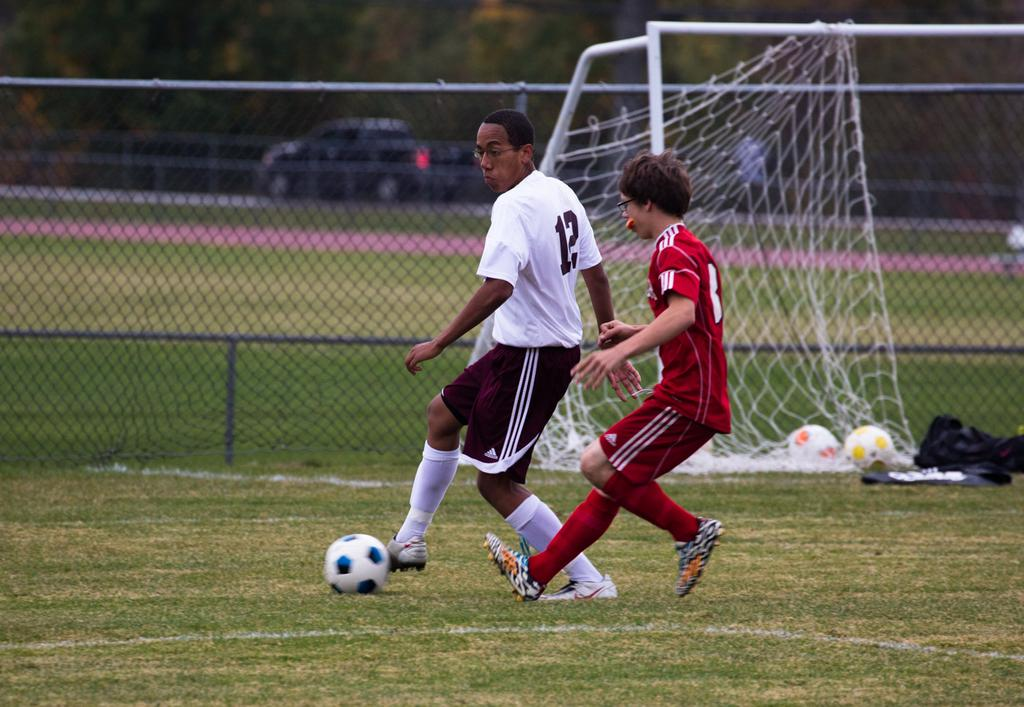<image>
Provide a brief description of the given image. A soccer player in Adidas shorts with the number 12 on his jersey has another player behind him. 